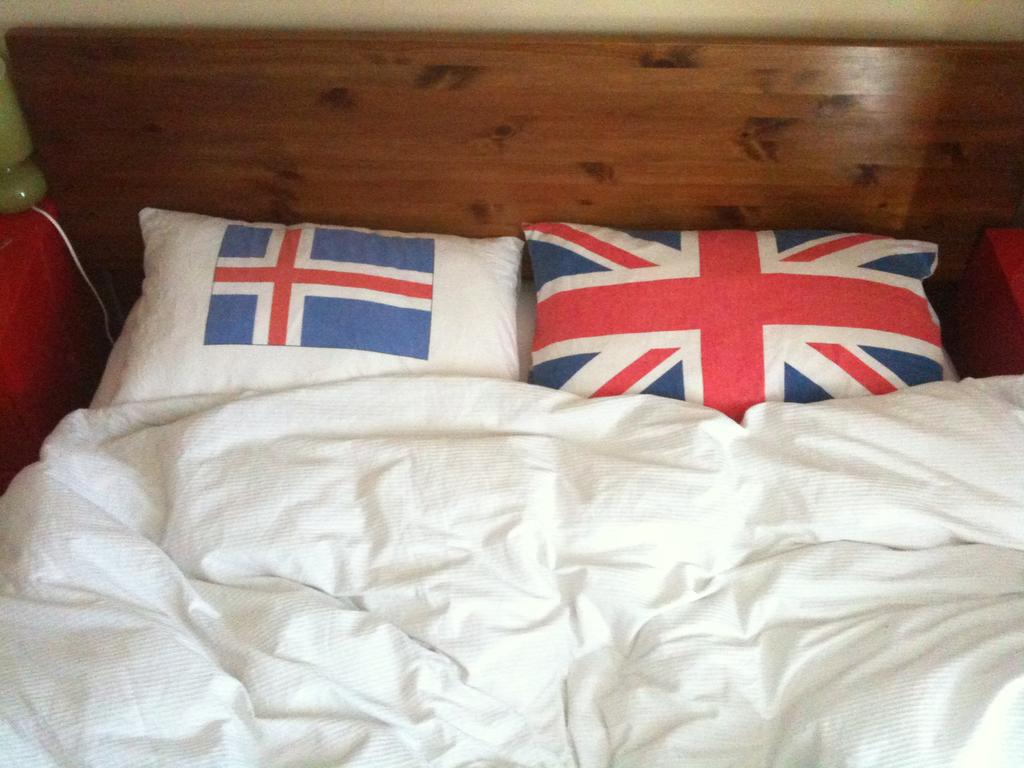What type of furniture is present in the image? There is a bed in the image. What color is the blanket on the bed? The blanket on the bed is white. What design can be seen on the pillows? The pillows on the bed have a flag design. What material is the bed made of? The bed is made of wood. How many snakes are coiled around the bedposts in the image? There are no snakes present in the image. What type of metal is used for the bed frame in the image? The bed frame material is not mentioned in the facts, but it is stated that the bed is made of wood. 